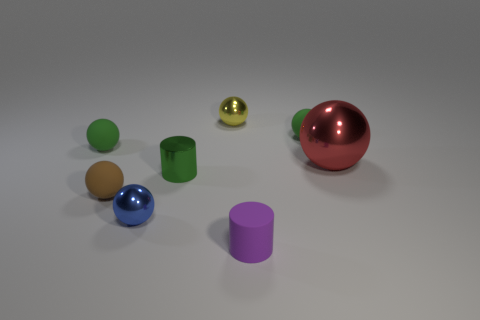How big is the green rubber sphere that is behind the green matte object to the left of the small brown matte object?
Provide a short and direct response. Small. What number of gray objects are either small spheres or cylinders?
Ensure brevity in your answer.  0. Are there fewer blue metallic spheres behind the yellow object than tiny metal cylinders behind the small green cylinder?
Offer a very short reply. No. Does the yellow metal ball have the same size as the red shiny object that is on the right side of the small yellow sphere?
Your answer should be compact. No. How many blue metallic spheres are the same size as the purple cylinder?
Your answer should be very brief. 1. What number of small things are red objects or yellow things?
Ensure brevity in your answer.  1. Are there any small purple matte objects?
Provide a succinct answer. Yes. Are there more yellow metallic spheres that are in front of the small blue shiny ball than red metallic objects left of the green metallic cylinder?
Offer a very short reply. No. What is the color of the small metallic object behind the green matte thing left of the tiny purple thing?
Provide a short and direct response. Yellow. Are there any other rubber things of the same color as the large object?
Ensure brevity in your answer.  No. 